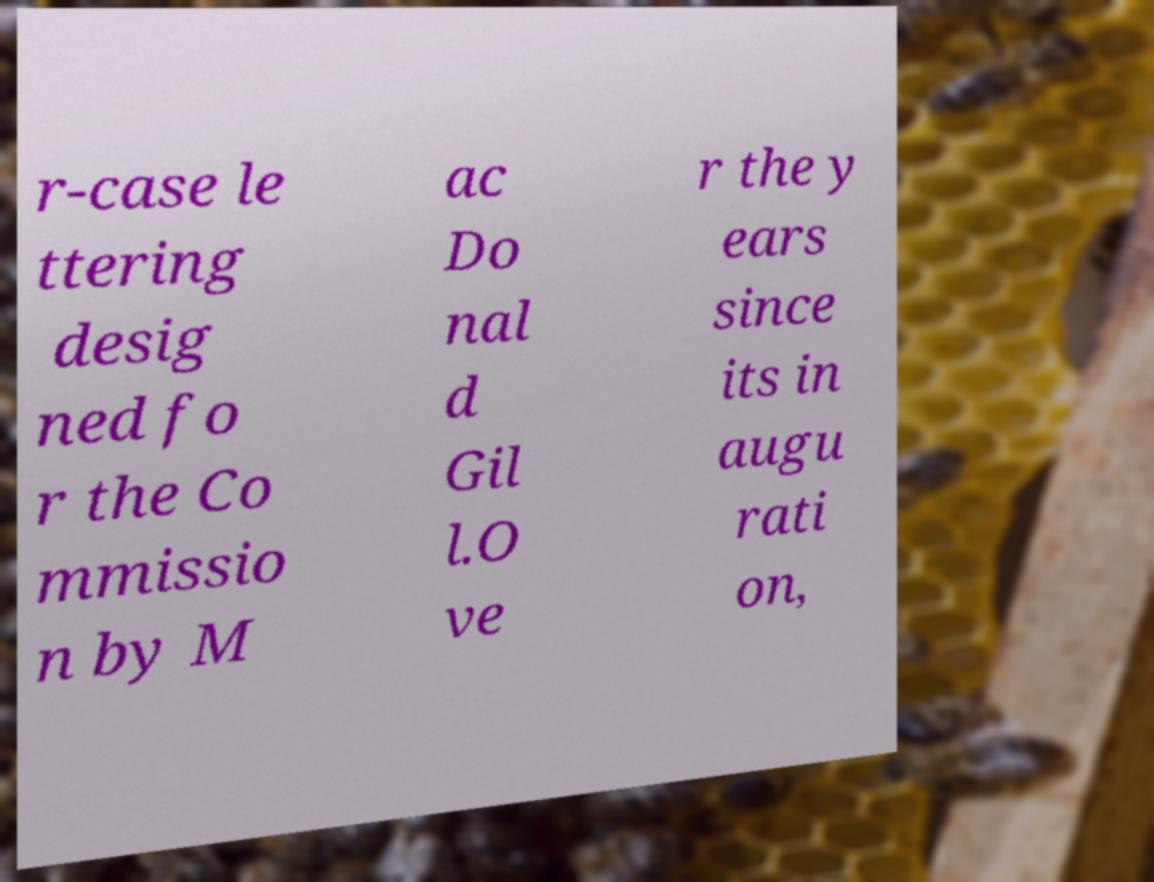What messages or text are displayed in this image? I need them in a readable, typed format. r-case le ttering desig ned fo r the Co mmissio n by M ac Do nal d Gil l.O ve r the y ears since its in augu rati on, 